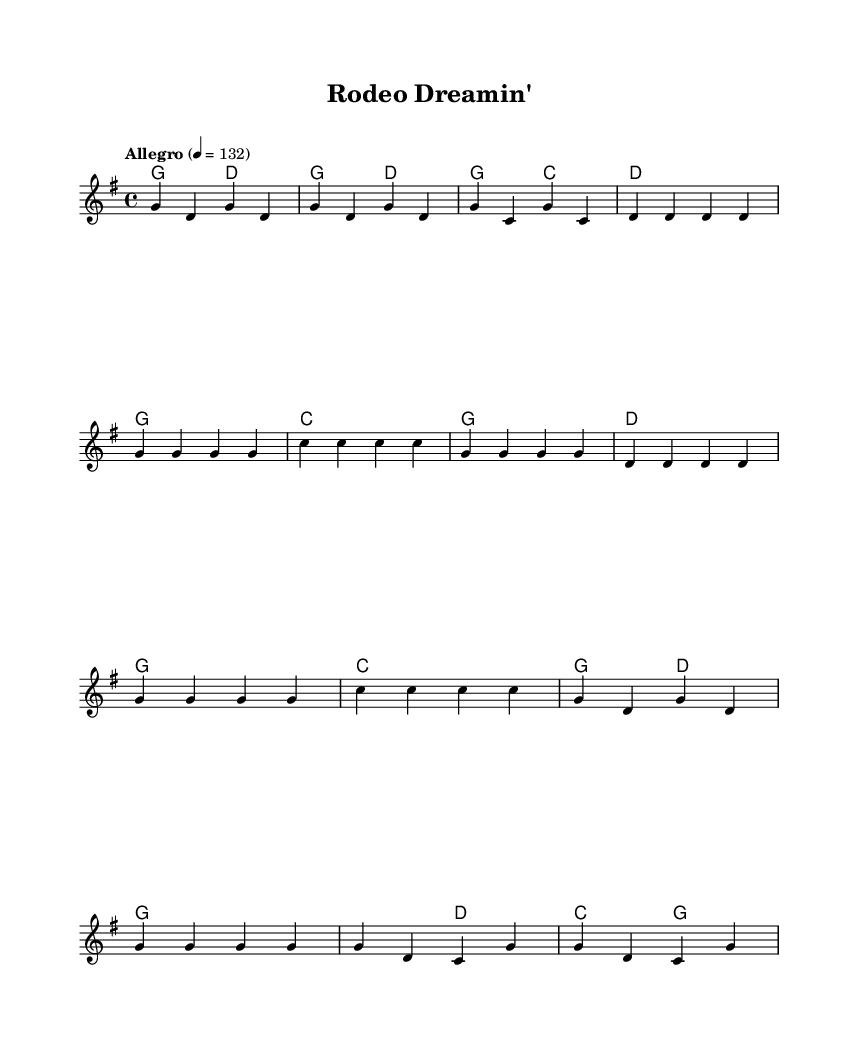What is the key signature of this music? The key signature shows one sharp, indicating the music is in G major.
Answer: G major What is the time signature of this music? The time signature is found at the beginning of the score and is written as 4/4, meaning there are four beats per measure.
Answer: 4/4 What is the tempo marking for this piece? The tempo marking "Allegro" indicates a fast and lively pace, specifically at a quarter note equals 132 beats per minute.
Answer: Allegro, 132 What are the first two chords in the introductory section? The first two chords appear right after the introduction and are G major and D major, displayed in the chord symbols.
Answer: G, D How many measures are there in the chorus section of the song? By examining the measures in the chorus, which are indicated by the slashes, there are a total of four measures.
Answer: 4 What is the name of this piece? The title is located at the top of the sheet music and is clearly labeled as "Rodeo Dreamin'."
Answer: Rodeo Dreamin' What type of music does this piece represent? The structure and themes of this sheet music align with the energetic and storytelling nature of bluegrass folk music, particularly about rodeo adventures.
Answer: Bluegrass 